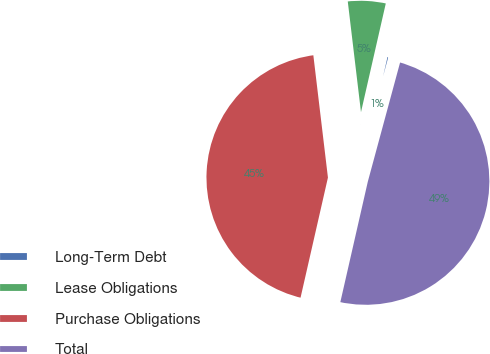Convert chart to OTSL. <chart><loc_0><loc_0><loc_500><loc_500><pie_chart><fcel>Long-Term Debt<fcel>Lease Obligations<fcel>Purchase Obligations<fcel>Total<nl><fcel>0.64%<fcel>5.46%<fcel>44.54%<fcel>49.36%<nl></chart> 